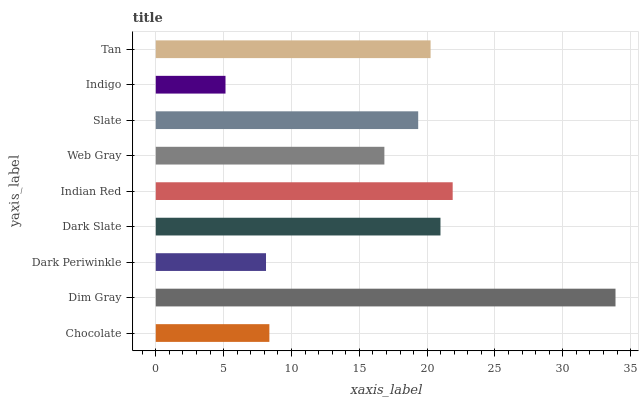Is Indigo the minimum?
Answer yes or no. Yes. Is Dim Gray the maximum?
Answer yes or no. Yes. Is Dark Periwinkle the minimum?
Answer yes or no. No. Is Dark Periwinkle the maximum?
Answer yes or no. No. Is Dim Gray greater than Dark Periwinkle?
Answer yes or no. Yes. Is Dark Periwinkle less than Dim Gray?
Answer yes or no. Yes. Is Dark Periwinkle greater than Dim Gray?
Answer yes or no. No. Is Dim Gray less than Dark Periwinkle?
Answer yes or no. No. Is Slate the high median?
Answer yes or no. Yes. Is Slate the low median?
Answer yes or no. Yes. Is Indigo the high median?
Answer yes or no. No. Is Tan the low median?
Answer yes or no. No. 